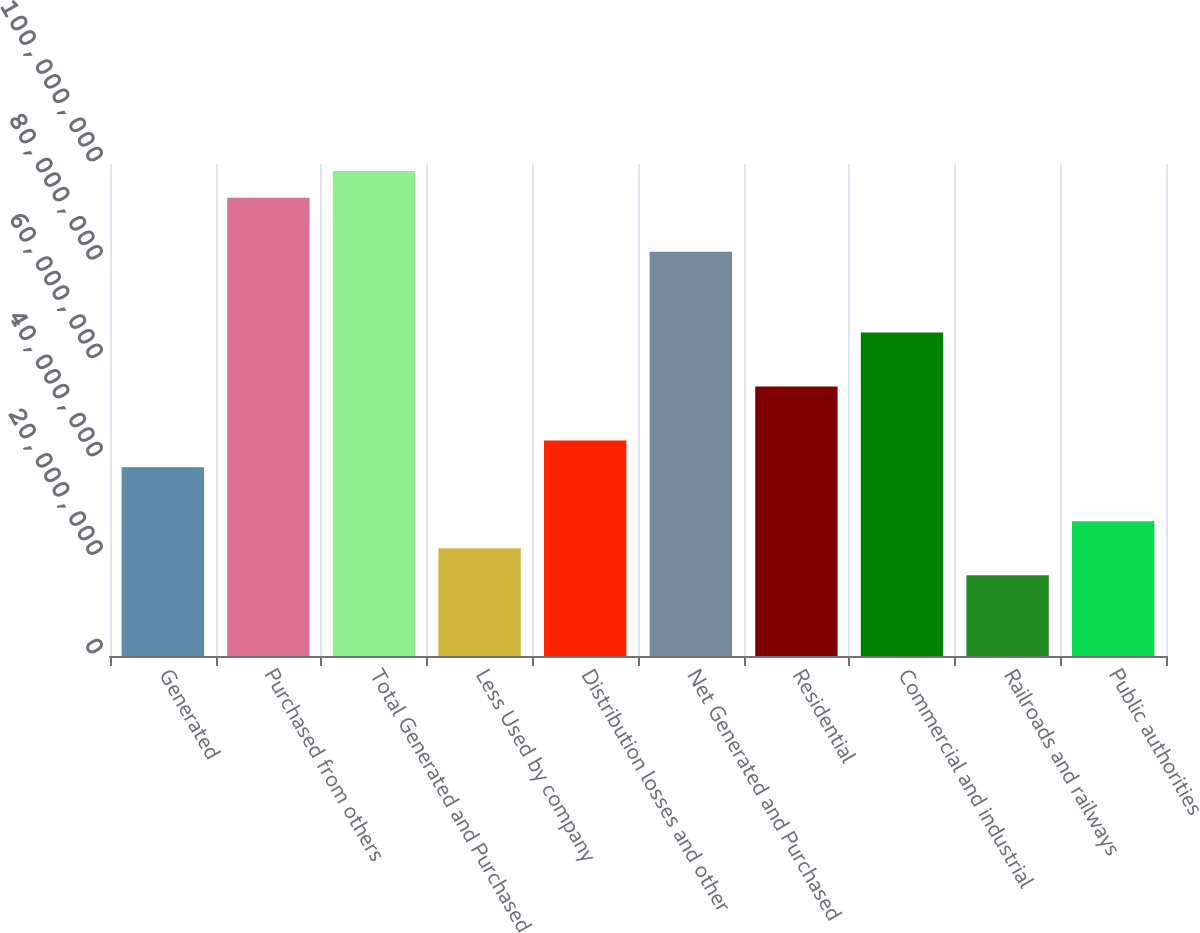Convert chart to OTSL. <chart><loc_0><loc_0><loc_500><loc_500><bar_chart><fcel>Generated<fcel>Purchased from others<fcel>Total Generated and Purchased<fcel>Less Used by company<fcel>Distribution losses and other<fcel>Net Generated and Purchased<fcel>Residential<fcel>Commercial and industrial<fcel>Railroads and railways<fcel>Public authorities<nl><fcel>3.83425e+07<fcel>9.31175e+07<fcel>9.8595e+07<fcel>2.191e+07<fcel>4.382e+07<fcel>8.21625e+07<fcel>5.4775e+07<fcel>6.573e+07<fcel>1.64325e+07<fcel>2.73875e+07<nl></chart> 